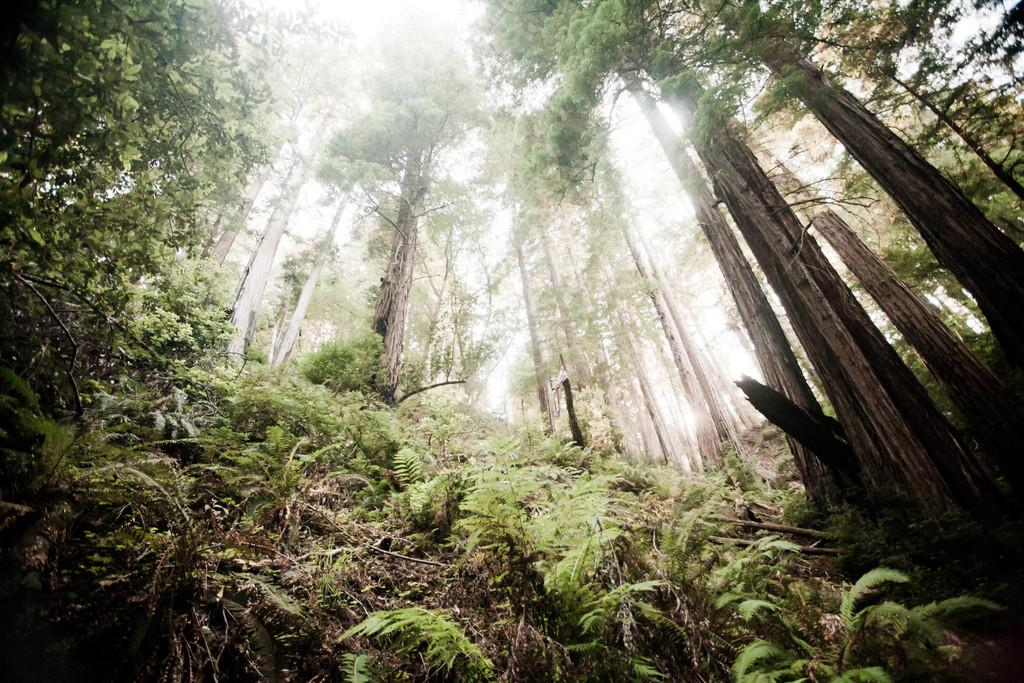What type of vegetation is visible in the image? There are many trees in the image. What part of the natural environment is visible in the image? The sky is visible in the image. Can you see the maid attempting to grant a wish in the image? There is no maid or any indication of a wish being granted in the image; it features trees and the sky. 